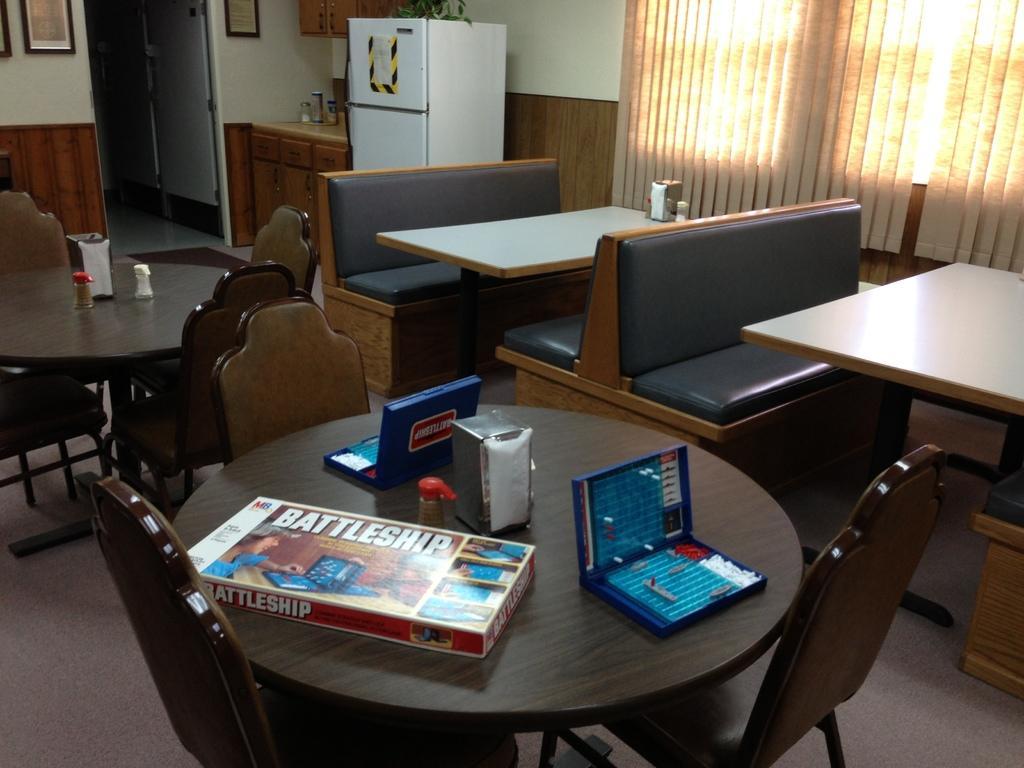In one or two sentences, can you explain what this image depicts? In this image there are tables with chairs and also tables with wooden benches for sitting. In the background there is a curtain for the window. Image also consists of fridge, plant and frames attached to the wall and on the table there is a playing box, tissue containers. At the bottom floor is visible. 